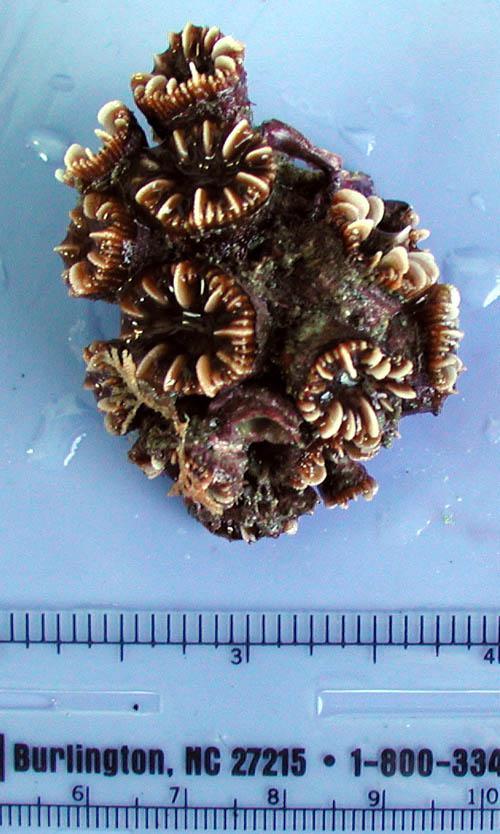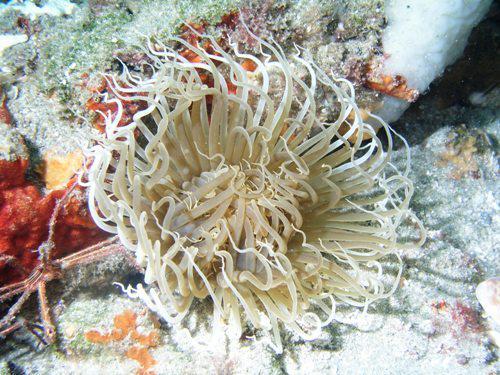The first image is the image on the left, the second image is the image on the right. Examine the images to the left and right. Is the description "There is one ruler visible in the image." accurate? Answer yes or no. Yes. The first image is the image on the left, the second image is the image on the right. Assess this claim about the two images: "The right image shows a single prominent anemone with tendrils mostly spreading outward around a reddish-orange center.". Correct or not? Answer yes or no. No. 